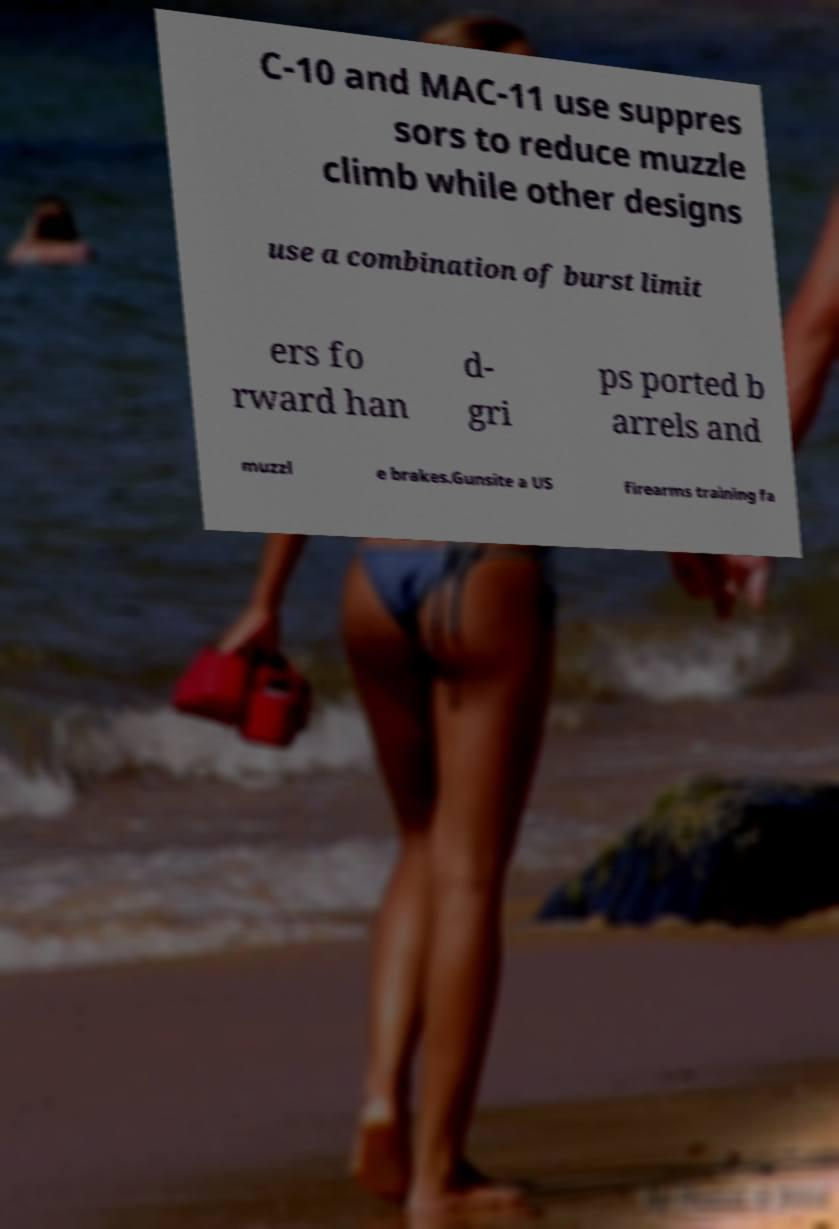Please identify and transcribe the text found in this image. C-10 and MAC-11 use suppres sors to reduce muzzle climb while other designs use a combination of burst limit ers fo rward han d- gri ps ported b arrels and muzzl e brakes.Gunsite a US firearms training fa 